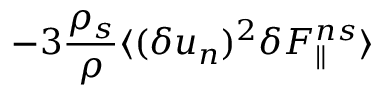Convert formula to latex. <formula><loc_0><loc_0><loc_500><loc_500>- 3 \frac { \rho _ { s } } { \rho } \langle { ( \delta u _ { n } ) ^ { 2 } \delta F _ { \| } ^ { n s } } \rangle</formula> 